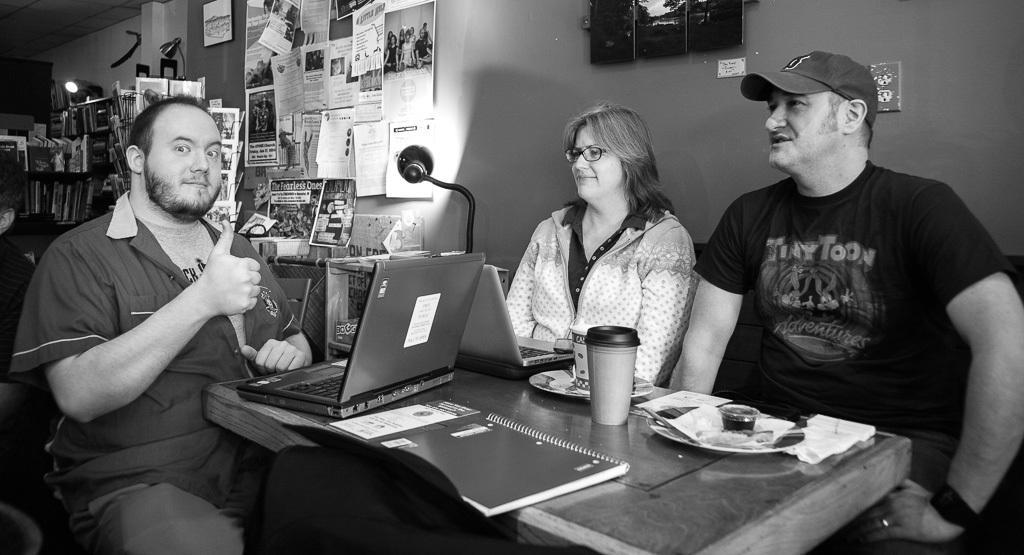Can you describe this image briefly? In the picture we can see three people sitting on the chairs two are men and one is women. One man is wearing a cap. In background we can find wall and stick papers and light. 